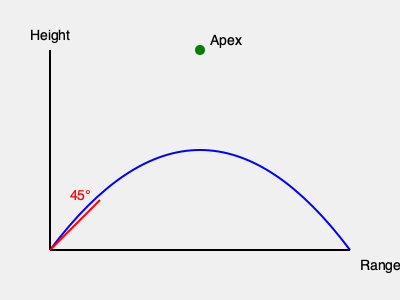In a ballistic trajectory exercise, a projectile is fired from ground level at an initial angle of 45° and an initial velocity of 100 m/s. Assuming no air resistance, what is the maximum height reached by the projectile? To solve this problem, we'll use the equations of motion for projectile motion:

1. The vertical component of the initial velocity:
   $v_y = v_0 \sin \theta = 100 \cdot \sin 45° = 100 \cdot \frac{\sqrt{2}}{2} \approx 70.71$ m/s

2. The time to reach the maximum height is when the vertical velocity becomes zero:
   $t_{max} = \frac{v_y}{g} = \frac{70.71}{9.8} \approx 7.22$ seconds

3. The maximum height is given by:
   $h_{max} = v_y \cdot \frac{t_{max}}{2} - \frac{1}{2}g(\frac{t_{max}}{2})^2$

4. Substituting the values:
   $h_{max} = 70.71 \cdot \frac{7.22}{2} - \frac{1}{2} \cdot 9.8 \cdot (\frac{7.22}{2})^2$

5. Calculating:
   $h_{max} = 255.26 - 127.63 = 127.63$ meters

Therefore, the maximum height reached by the projectile is approximately 127.63 meters.
Answer: 127.63 meters 